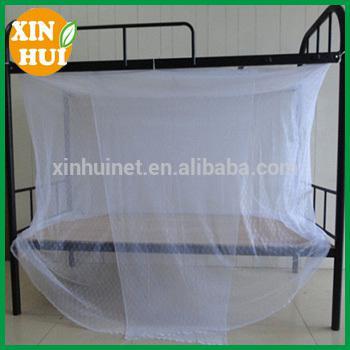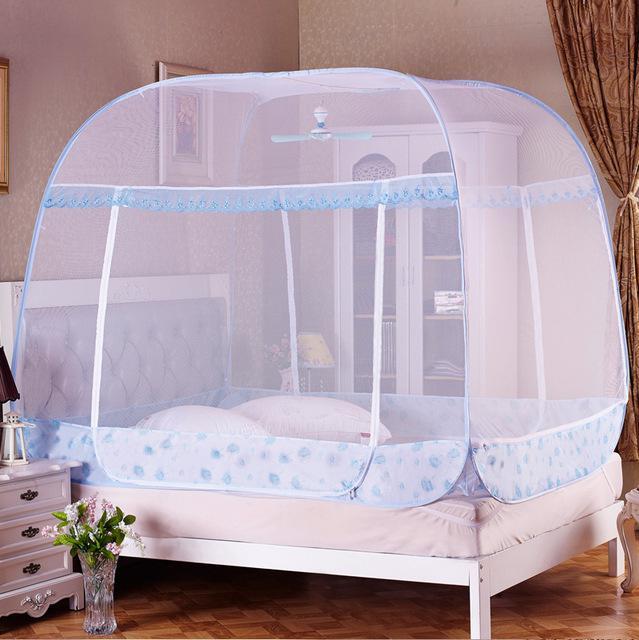The first image is the image on the left, the second image is the image on the right. For the images shown, is this caption "Each image shows a bed with purple ruffled layers above it, and one of the images shows sheer purple draping at least two sides of the bed from a canopy the same shape as the bed." true? Answer yes or no. No. 